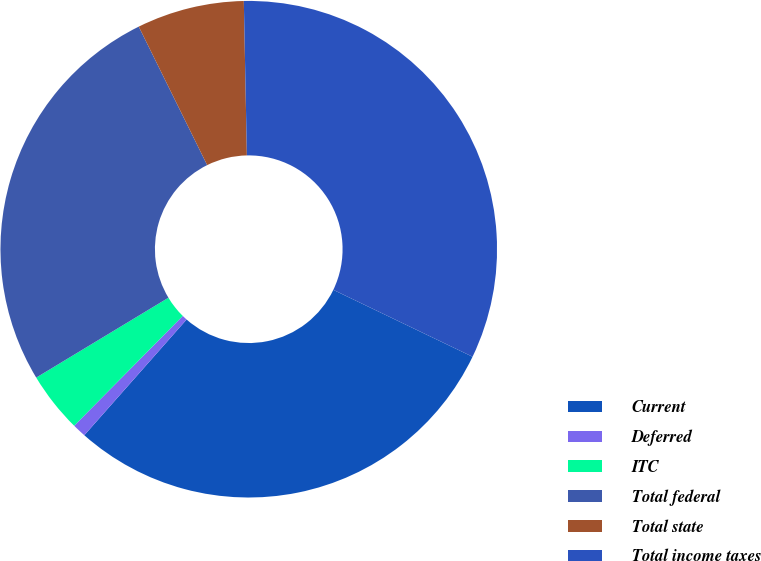Convert chart. <chart><loc_0><loc_0><loc_500><loc_500><pie_chart><fcel>Current<fcel>Deferred<fcel>ITC<fcel>Total federal<fcel>Total state<fcel>Total income taxes<nl><fcel>29.4%<fcel>0.89%<fcel>3.94%<fcel>26.35%<fcel>6.99%<fcel>32.45%<nl></chart> 